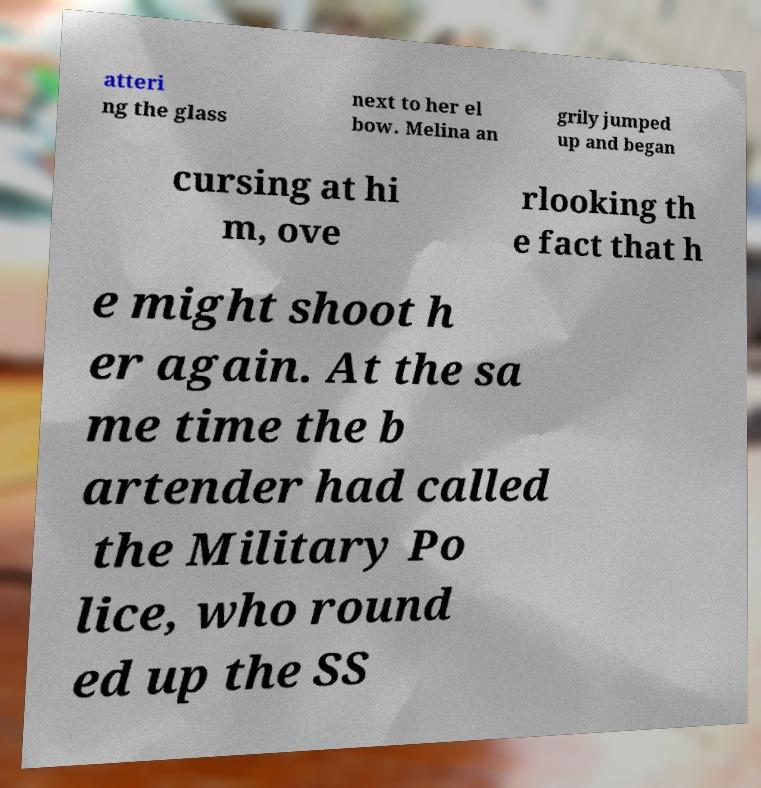Please read and relay the text visible in this image. What does it say? atteri ng the glass next to her el bow. Melina an grily jumped up and began cursing at hi m, ove rlooking th e fact that h e might shoot h er again. At the sa me time the b artender had called the Military Po lice, who round ed up the SS 